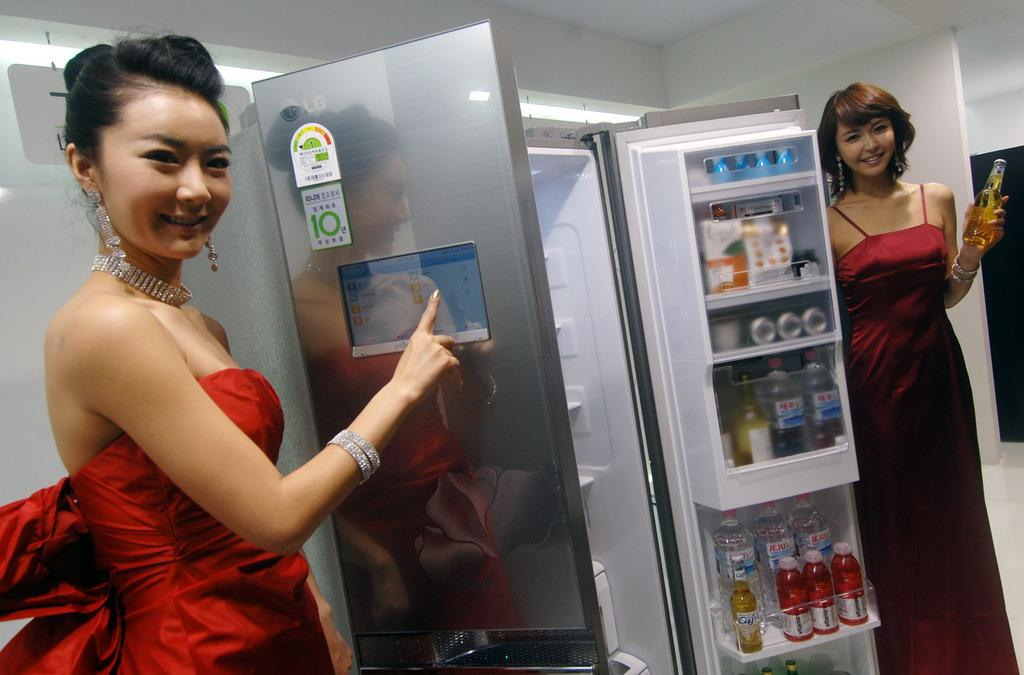<image>
Render a clear and concise summary of the photo. A female model pointing at a screen of an LG fridge 